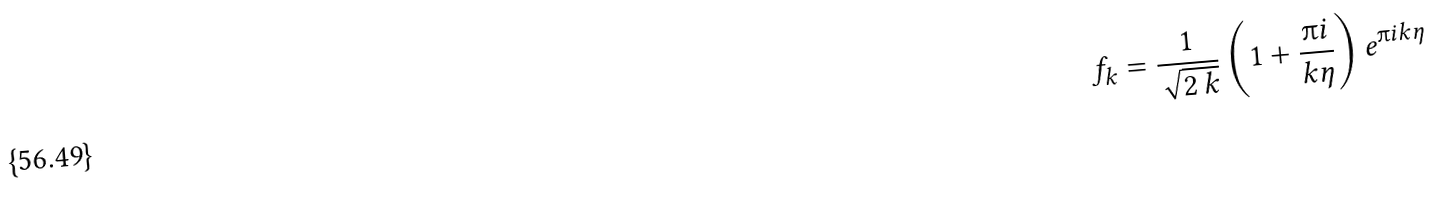<formula> <loc_0><loc_0><loc_500><loc_500>f _ { k } = \frac { 1 } { \sqrt { 2 \, k } } \left ( 1 + \frac { \i i } { k \eta } \right ) { e ^ { \i i k \eta } }</formula> 